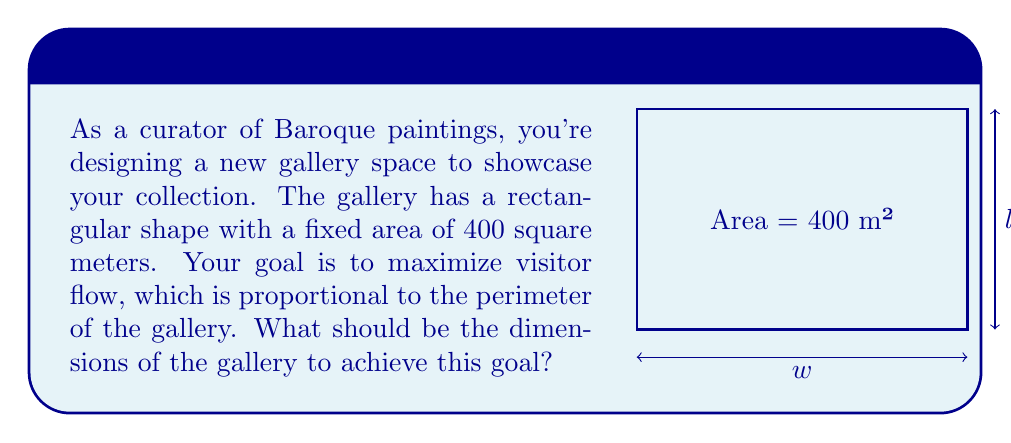Teach me how to tackle this problem. Let's approach this step-by-step:

1) Let $w$ be the width and $l$ be the length of the gallery.

2) Given that the area is fixed at 400 square meters:

   $$w \cdot l = 400$$

3) The perimeter $P$ (which we want to maximize) is:

   $$P = 2w + 2l$$

4) We can express $l$ in terms of $w$ using the area constraint:

   $$l = \frac{400}{w}$$

5) Substituting this into the perimeter equation:

   $$P = 2w + 2(\frac{400}{w}) = 2w + \frac{800}{w}$$

6) To find the maximum, we differentiate $P$ with respect to $w$ and set it to zero:

   $$\frac{dP}{dw} = 2 - \frac{800}{w^2} = 0$$

7) Solving this equation:

   $$2 = \frac{800}{w^2}$$
   $$w^2 = 400$$
   $$w = 20$$

8) Since $w \cdot l = 400$, if $w = 20$, then $l = 20$ as well.

9) To confirm this is a maximum (not a minimum), we can check the second derivative is negative at this point (which it is).

Therefore, the gallery should be a square with sides of 20 meters to maximize visitor flow.
Answer: 20m x 20m square 